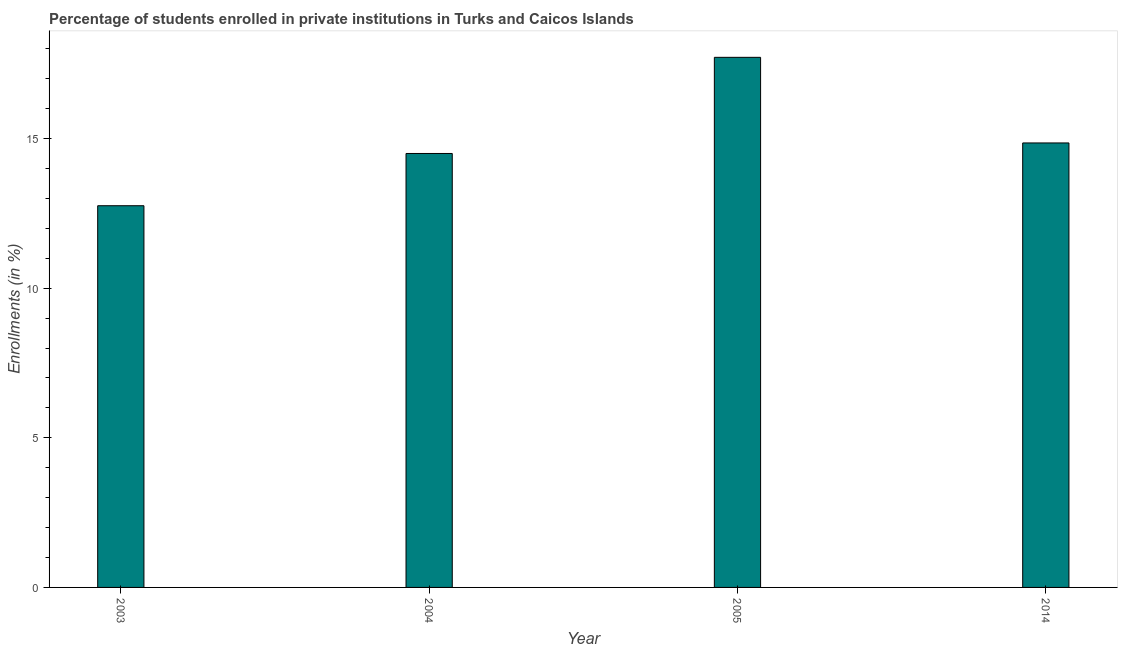What is the title of the graph?
Keep it short and to the point. Percentage of students enrolled in private institutions in Turks and Caicos Islands. What is the label or title of the X-axis?
Your answer should be very brief. Year. What is the label or title of the Y-axis?
Your response must be concise. Enrollments (in %). What is the enrollments in private institutions in 2004?
Ensure brevity in your answer.  14.5. Across all years, what is the maximum enrollments in private institutions?
Give a very brief answer. 17.72. Across all years, what is the minimum enrollments in private institutions?
Your answer should be compact. 12.76. In which year was the enrollments in private institutions minimum?
Keep it short and to the point. 2003. What is the sum of the enrollments in private institutions?
Your answer should be very brief. 59.83. What is the difference between the enrollments in private institutions in 2003 and 2005?
Keep it short and to the point. -4.96. What is the average enrollments in private institutions per year?
Give a very brief answer. 14.96. What is the median enrollments in private institutions?
Your answer should be compact. 14.68. Do a majority of the years between 2003 and 2004 (inclusive) have enrollments in private institutions greater than 14 %?
Provide a succinct answer. No. What is the ratio of the enrollments in private institutions in 2003 to that in 2005?
Make the answer very short. 0.72. Is the enrollments in private institutions in 2003 less than that in 2004?
Offer a very short reply. Yes. What is the difference between the highest and the second highest enrollments in private institutions?
Your response must be concise. 2.86. Is the sum of the enrollments in private institutions in 2005 and 2014 greater than the maximum enrollments in private institutions across all years?
Provide a short and direct response. Yes. What is the difference between the highest and the lowest enrollments in private institutions?
Your answer should be compact. 4.96. How many bars are there?
Your response must be concise. 4. Are all the bars in the graph horizontal?
Your response must be concise. No. How many years are there in the graph?
Your response must be concise. 4. What is the difference between two consecutive major ticks on the Y-axis?
Your answer should be compact. 5. What is the Enrollments (in %) of 2003?
Keep it short and to the point. 12.76. What is the Enrollments (in %) in 2004?
Ensure brevity in your answer.  14.5. What is the Enrollments (in %) of 2005?
Give a very brief answer. 17.72. What is the Enrollments (in %) in 2014?
Your answer should be very brief. 14.85. What is the difference between the Enrollments (in %) in 2003 and 2004?
Offer a very short reply. -1.75. What is the difference between the Enrollments (in %) in 2003 and 2005?
Your answer should be very brief. -4.96. What is the difference between the Enrollments (in %) in 2003 and 2014?
Offer a very short reply. -2.1. What is the difference between the Enrollments (in %) in 2004 and 2005?
Give a very brief answer. -3.21. What is the difference between the Enrollments (in %) in 2004 and 2014?
Offer a terse response. -0.35. What is the difference between the Enrollments (in %) in 2005 and 2014?
Give a very brief answer. 2.86. What is the ratio of the Enrollments (in %) in 2003 to that in 2004?
Your answer should be very brief. 0.88. What is the ratio of the Enrollments (in %) in 2003 to that in 2005?
Offer a very short reply. 0.72. What is the ratio of the Enrollments (in %) in 2003 to that in 2014?
Keep it short and to the point. 0.86. What is the ratio of the Enrollments (in %) in 2004 to that in 2005?
Provide a short and direct response. 0.82. What is the ratio of the Enrollments (in %) in 2005 to that in 2014?
Ensure brevity in your answer.  1.19. 